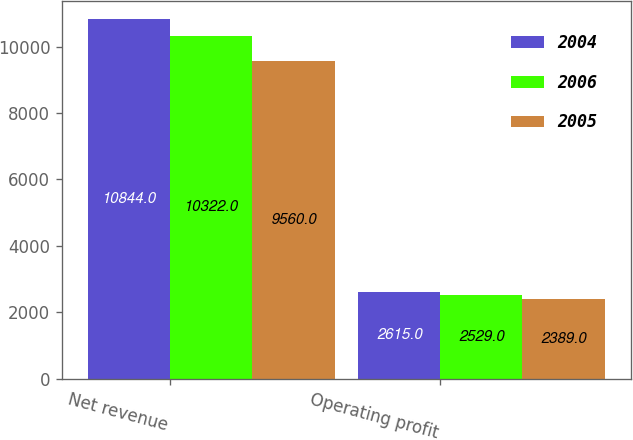<chart> <loc_0><loc_0><loc_500><loc_500><stacked_bar_chart><ecel><fcel>Net revenue<fcel>Operating profit<nl><fcel>2004<fcel>10844<fcel>2615<nl><fcel>2006<fcel>10322<fcel>2529<nl><fcel>2005<fcel>9560<fcel>2389<nl></chart> 